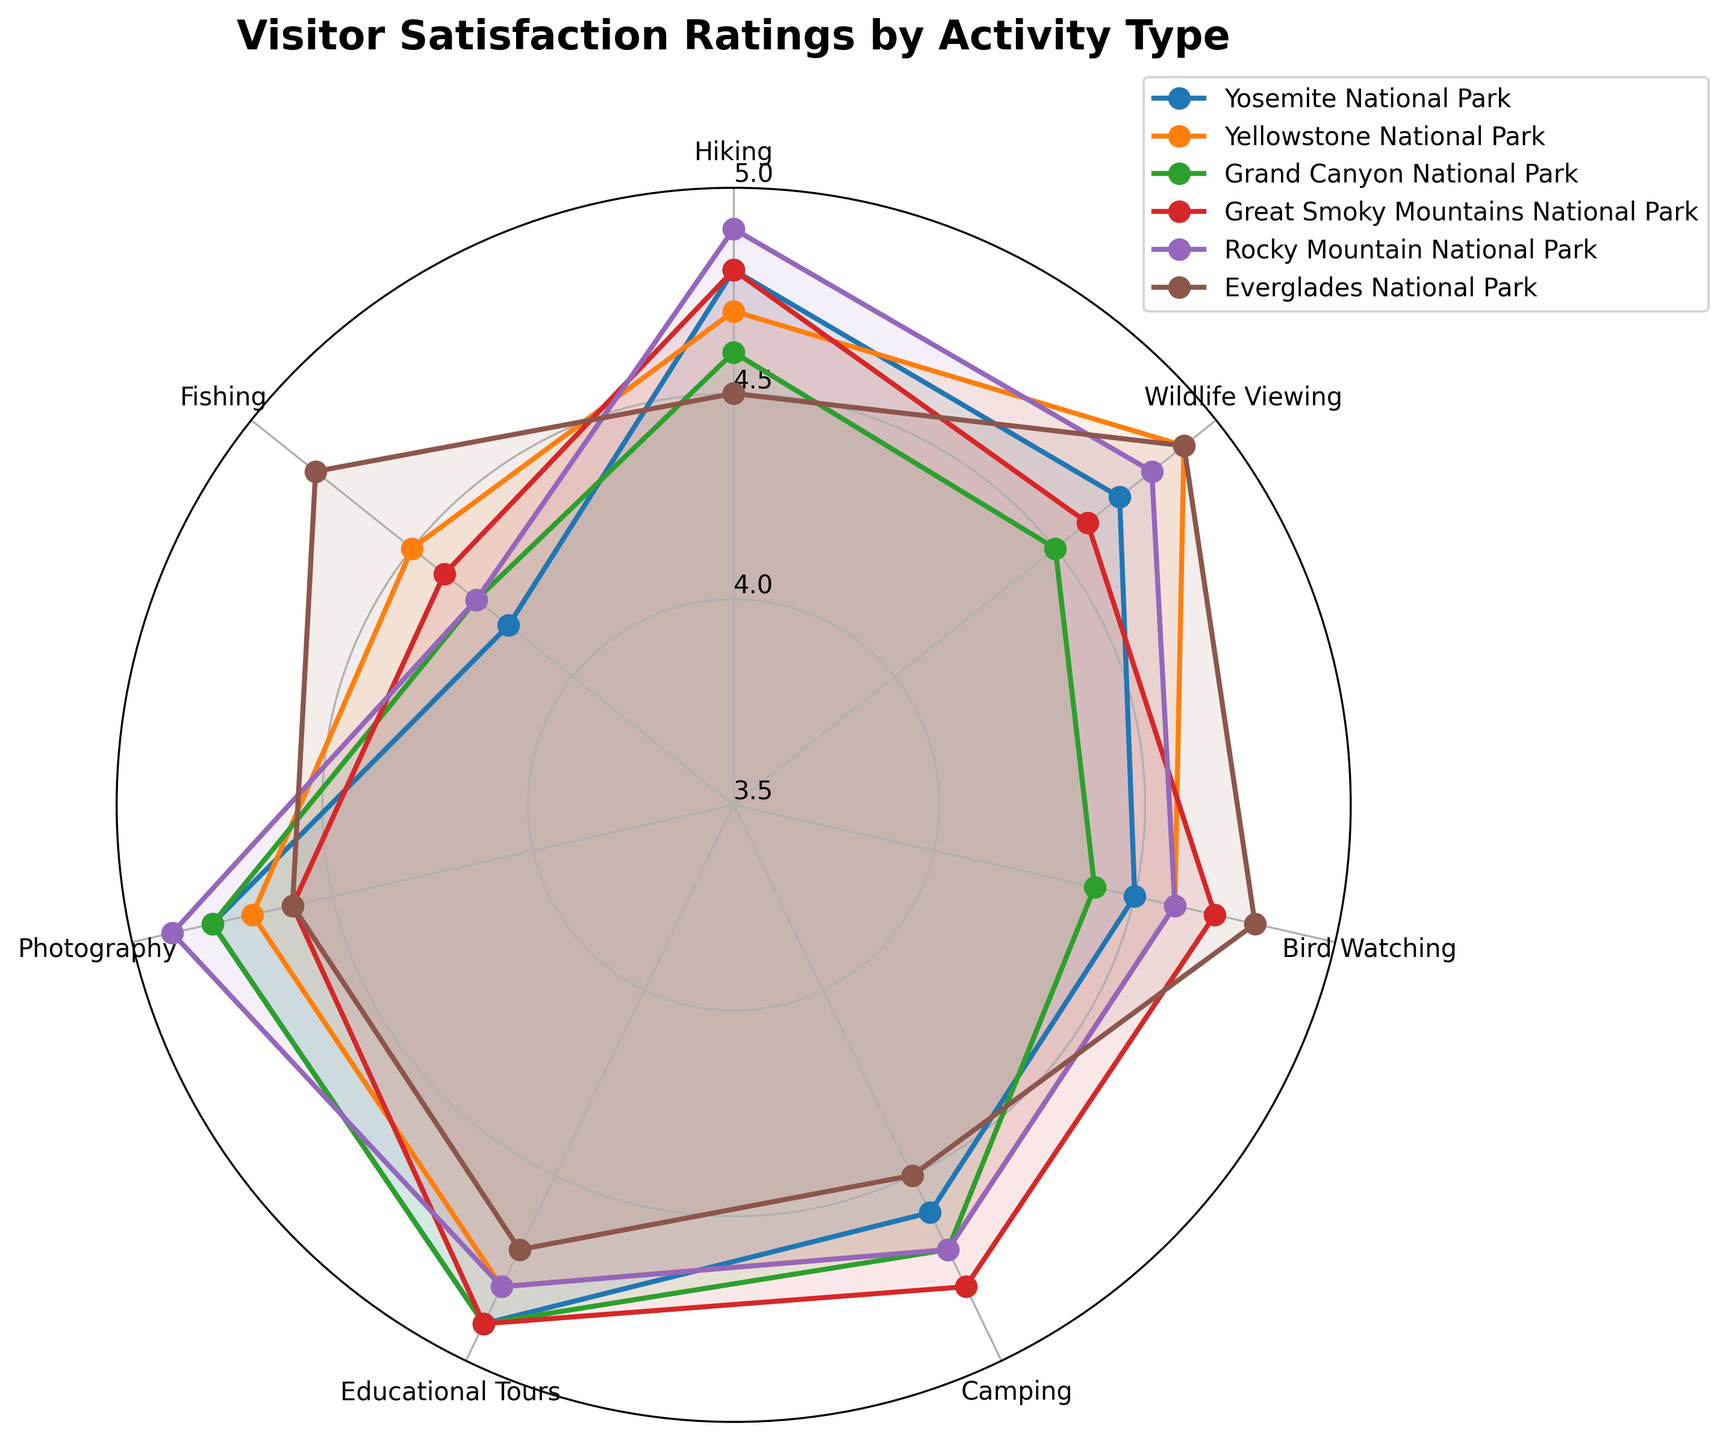Which park has the highest visitor satisfaction rating for Hiking? To find the highest satisfaction rating for Hiking, compare the Hiking values for each park. The highest rating is 4.9, which belongs to Rocky Mountain National Park.
Answer: Rocky Mountain National Park Which activity has the lowest overall satisfaction across all parks? Compare the ratings for all activities across all parks. The lowest rating is for Fishing in Yosemite National Park, which is 4.2.
Answer: Fishing Compare visitor satisfaction ratings for Educational Tours between Yosemite National Park and Great Smoky Mountains National Park. Which one is higher? Look at the satisfaction ratings for Educational Tours in both parks. Yosemite has 4.9, and Great Smoky Mountains also has 4.9, indicating they are equal.
Answer: Equal Which park has the most consistent visitor satisfaction ratings across all activities? To find the most consistent park, look for the one with the smallest variation in ratings across activities. Yosemite National Park has many high ratings and small variability, making it a likely candidate.
Answer: Yosemite National Park What is the average satisfaction rating for Wildlife Viewing across all six parks? Add the ratings for Wildlife Viewing in all parks and divide by the number of parks. (4.7 + 4.9 + 4.5 + 4.6 + 4.8 + 4.9) / 6 results in 4.73.
Answer: 4.73 Identify the park with the lowest satisfaction rating for Bird Watching. Compare the Bird Watching ratings for each park and find the lowest one. Yosemite National Park has the lowest rating at 4.5.
Answer: Yosemite National Park Which park offers the best visitor satisfaction rating for Photography? Compare the Photography ratings for each park. Yosemite and Grand Canyon both have 4.8, and Rocky Mountain has 4.9, so Rocky Mountain is the highest.
Answer: Rocky Mountain National Park Out of Yosemite National Park and Everglades National Park, which one has a higher satisfaction rating for Fishing? Compare the Fishing ratings for both parks. Yosemite has 4.2, while Everglades has 4.8. Thus, Everglades has a higher rating.
Answer: Everglades National Park Is the satisfaction rating for Camping in Grand Canyon National Park higher than the rating for Camping in Yellowstone National Park? Compare the Camping ratings: Grand Canyon has 4.7, and Yellowstone also has 4.7, so they are equal.
Answer: Equal Which activity has the highest average rating across all parks? Calculate the average rating for each activity across all parks. Educational Tours have the highest average rating at 4.87.
Answer: Educational Tours 